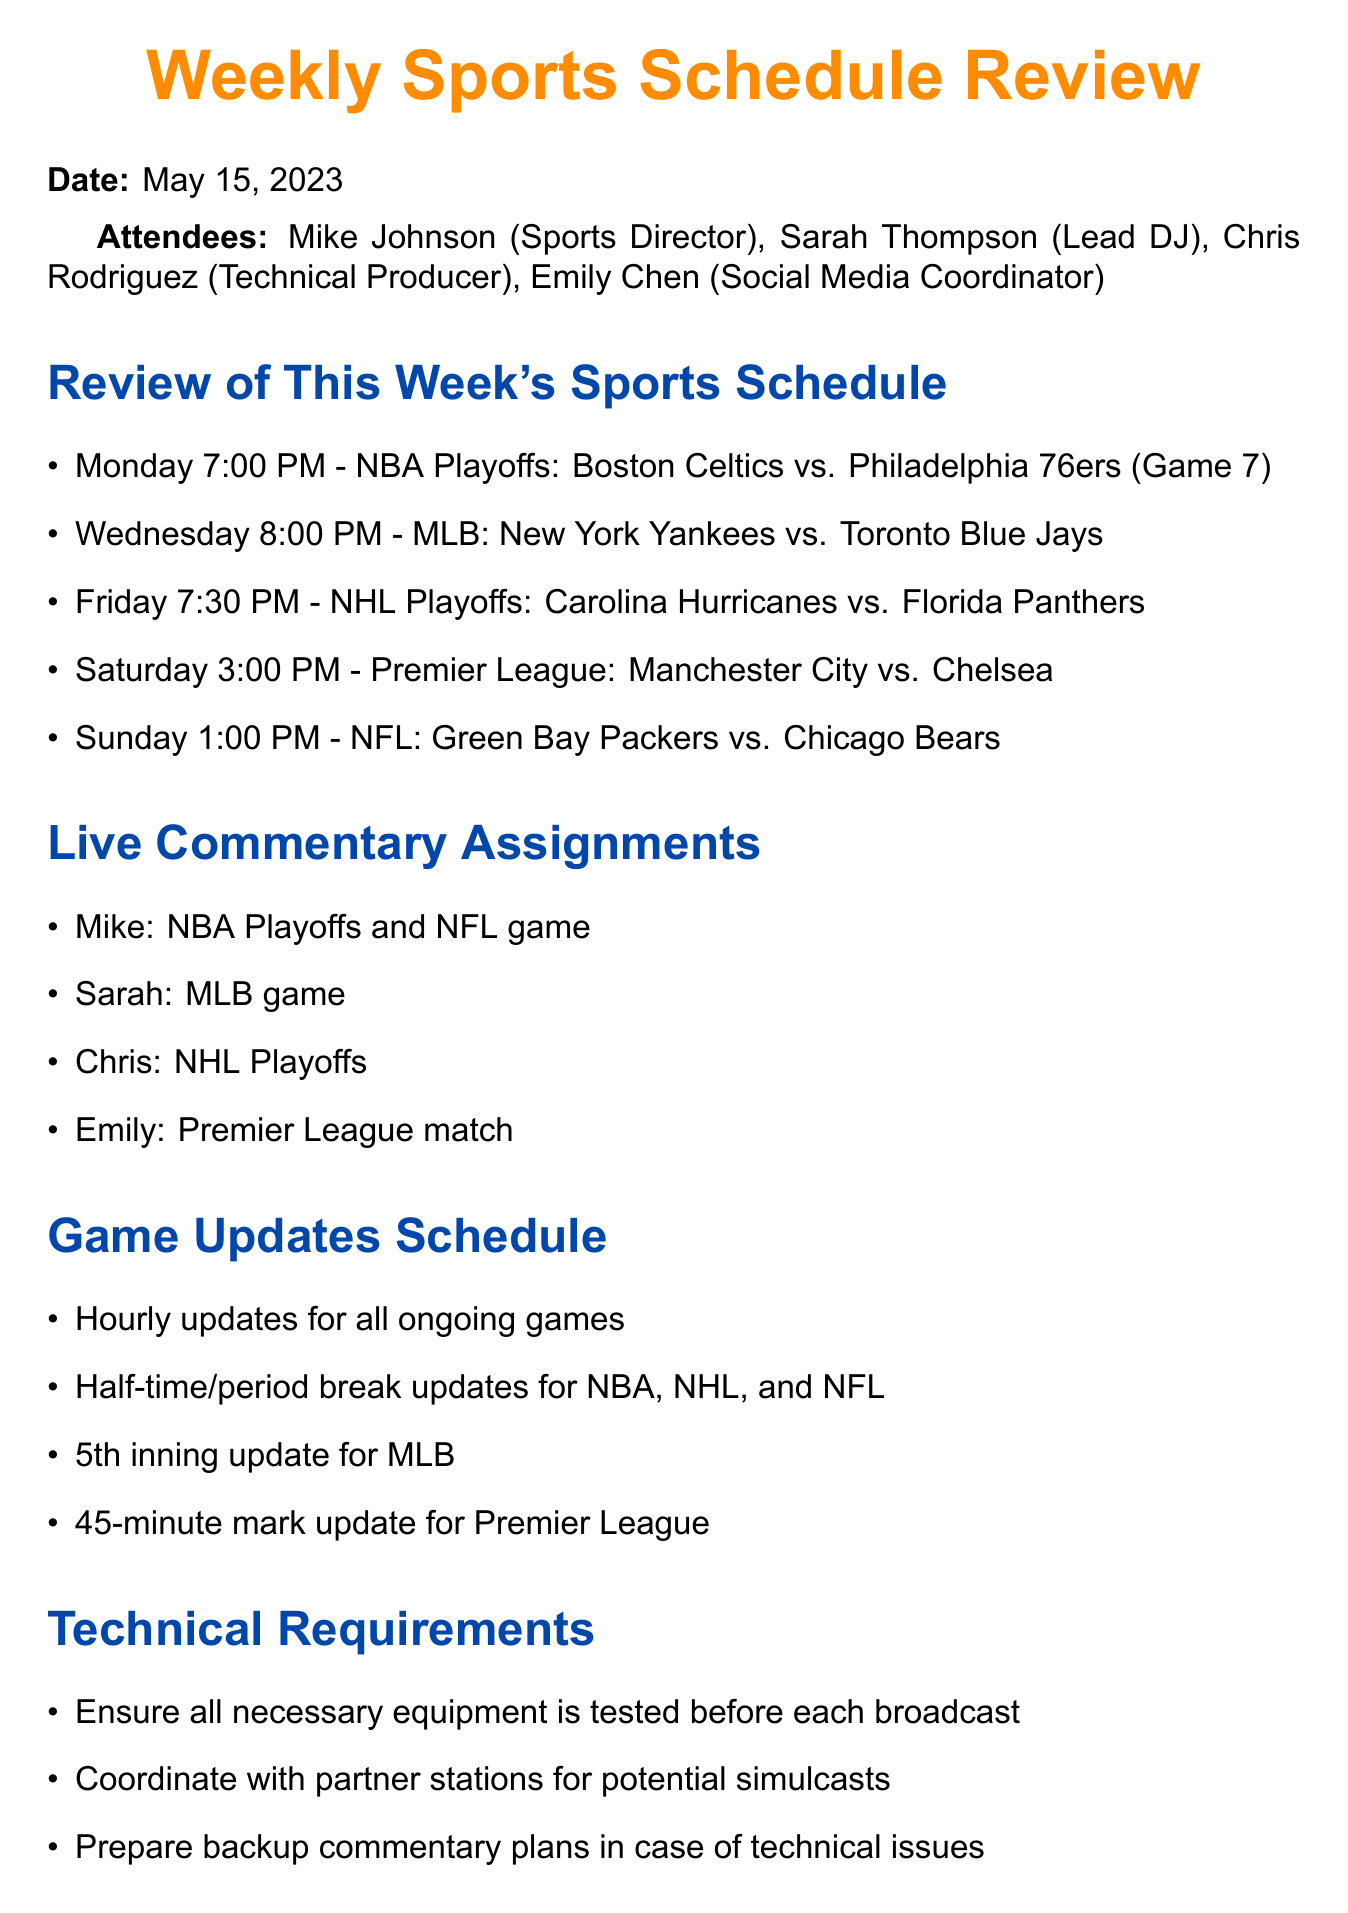What is the date of the meeting? The meeting date is specified at the beginning of the document.
Answer: May 15, 2023 Who is responsible for the NBA Playoffs commentary? The document lists commentary assignments under the Live Commentary Assignments section.
Answer: Mike What time is the Premier League match scheduled for? The schedule includes exact times for each game under the Review of This Week's Sports Schedule section.
Answer: 3:00 PM How many attendees were there at the meeting? The attendees are listed at the top of the document.
Answer: Four What action item is assigned to Emily? The action items section outlines tasks assigned to each attendee.
Answer: Create social media content calendar by Tuesday Which sport is Chris covering? The Live Commentary Assignments section provides details on which commentator covers which sport.
Answer: NHL Playoffs What update is scheduled at the 5th inning for MLB games? The Game Updates Schedule lists specific update times for different sports.
Answer: Update What is the main purpose of the social media integration? The Social Media Integration section describes objectives related to engaging listeners.
Answer: Listener interaction What type of updates are scheduled for NBA, NHL, and NFL games? The document specifies the update types in the Game Updates Schedule section.
Answer: Half-time/period break updates 